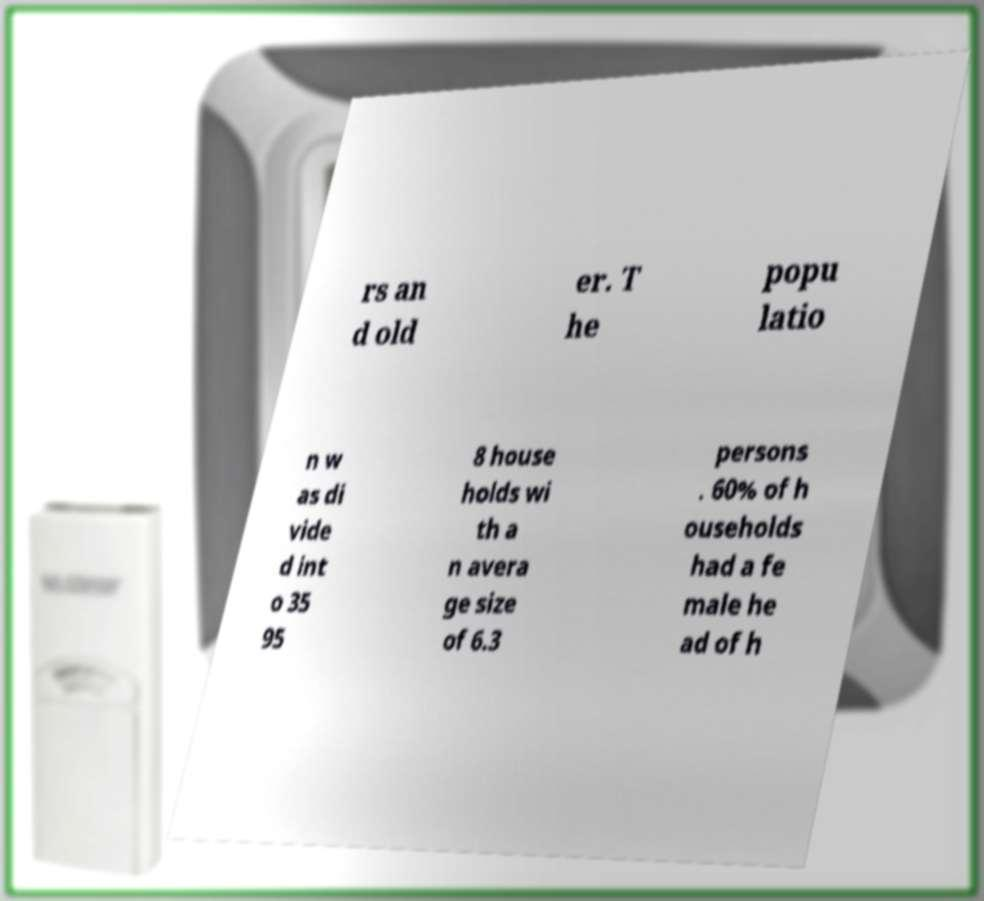For documentation purposes, I need the text within this image transcribed. Could you provide that? rs an d old er. T he popu latio n w as di vide d int o 35 95 8 house holds wi th a n avera ge size of 6.3 persons . 60% of h ouseholds had a fe male he ad of h 